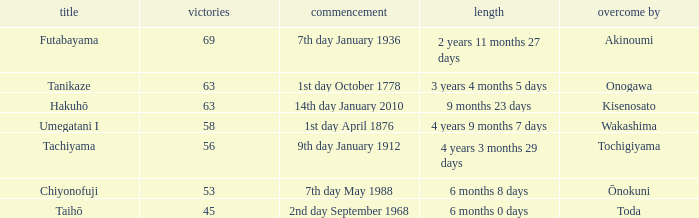How many wins were held before being defeated by toda? 1.0. 